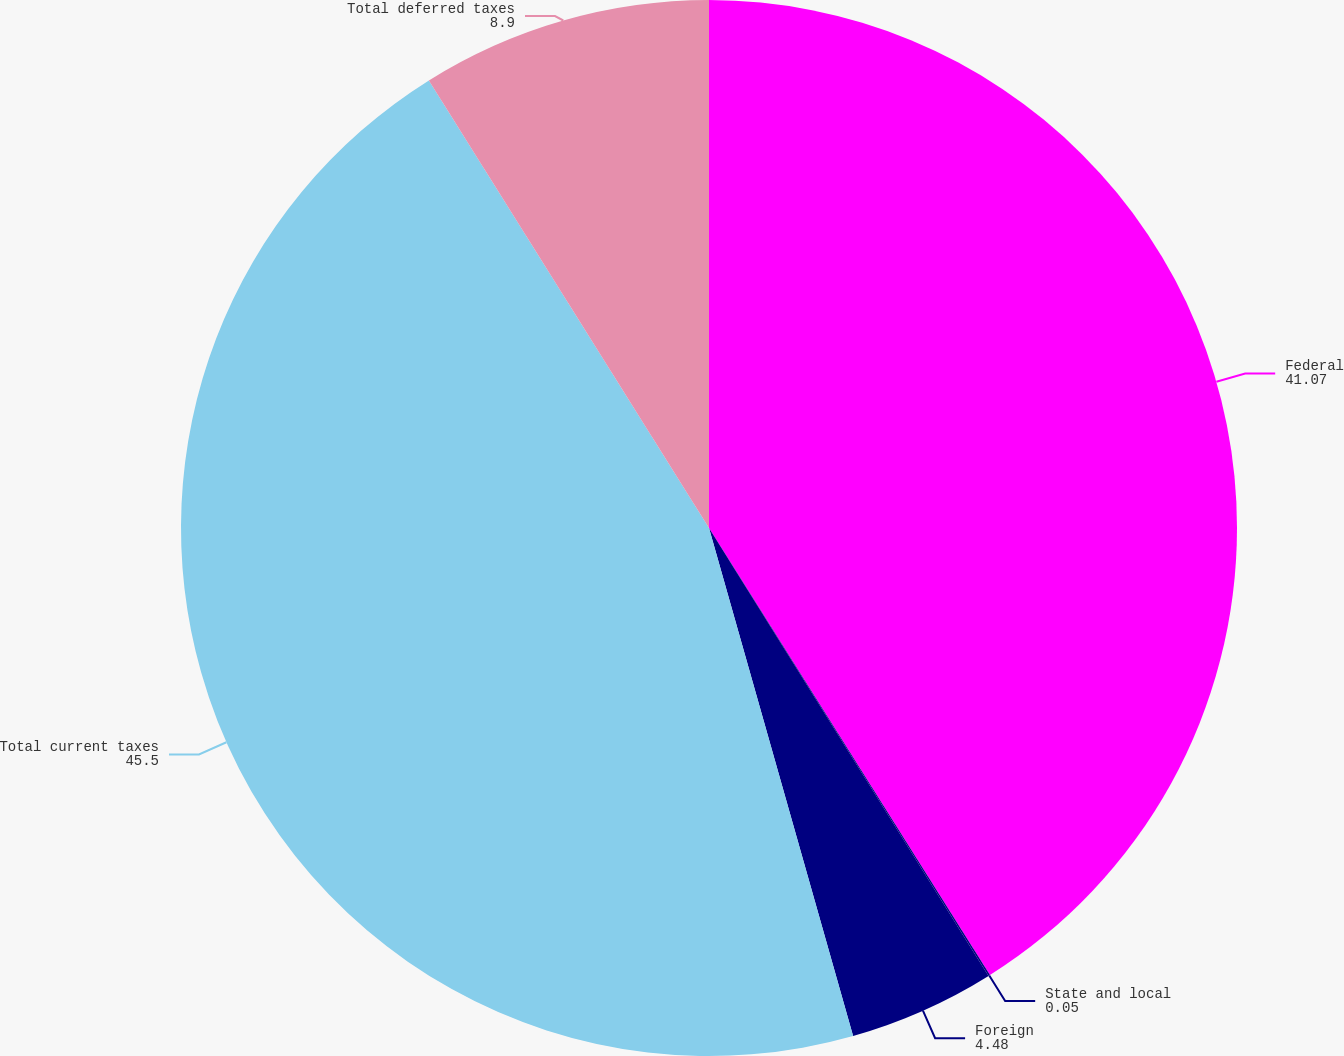<chart> <loc_0><loc_0><loc_500><loc_500><pie_chart><fcel>Federal<fcel>State and local<fcel>Foreign<fcel>Total current taxes<fcel>Total deferred taxes<nl><fcel>41.07%<fcel>0.05%<fcel>4.48%<fcel>45.5%<fcel>8.9%<nl></chart> 